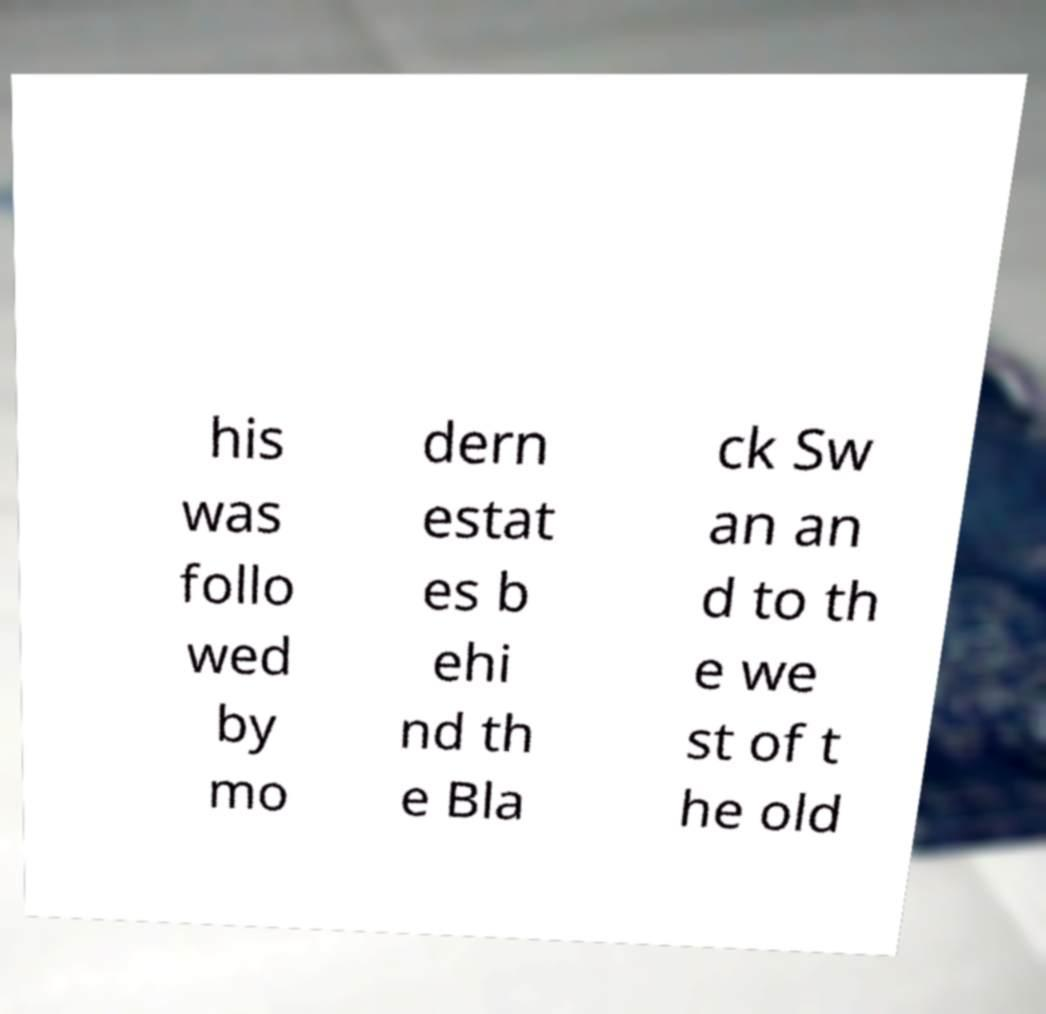Could you assist in decoding the text presented in this image and type it out clearly? his was follo wed by mo dern estat es b ehi nd th e Bla ck Sw an an d to th e we st of t he old 